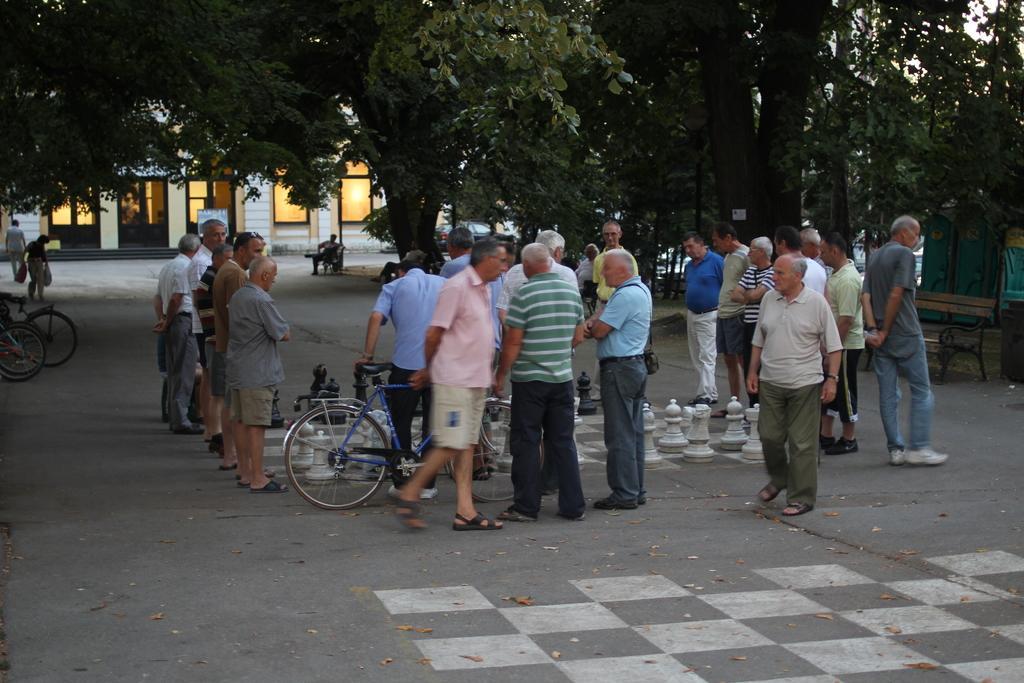Could you give a brief overview of what you see in this image? There is a chess board in the center of the image on a road and there are people those who are standing around it and there is a bench on the right side, there are bicycles in the image and there are trees, vehicles, and windows in the background area. 